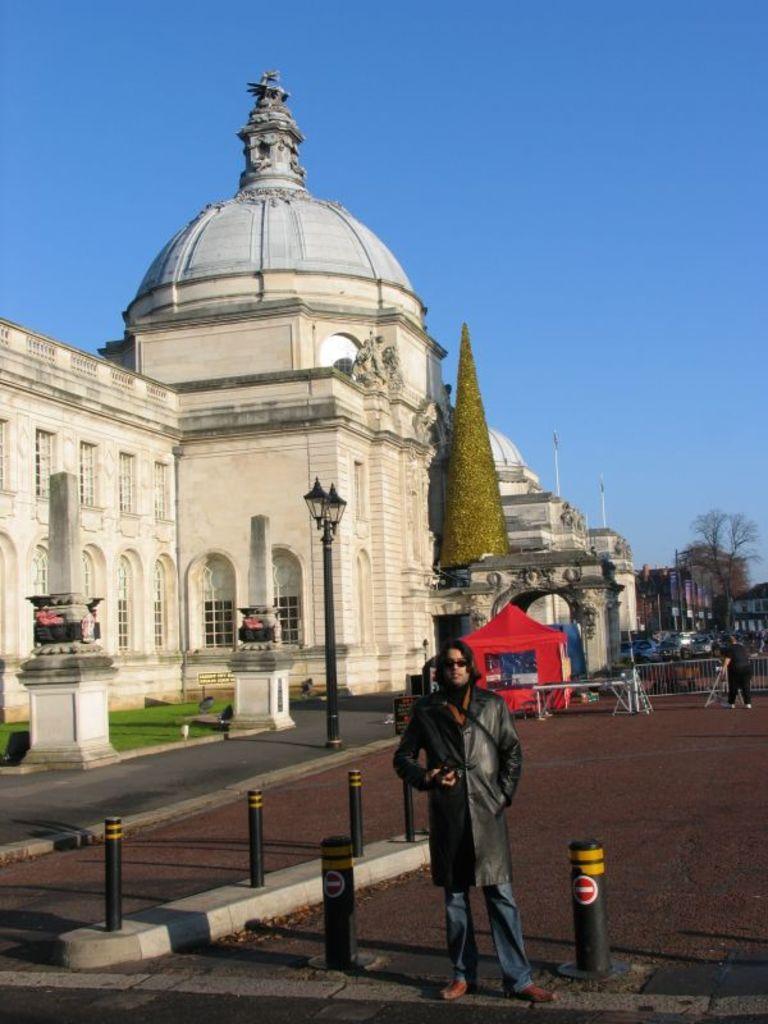Can you describe this image briefly? In this image, we can see a man standing, we can see the road, there is a building and we can see a dome. There are some trees, at the top we can see the sky. 